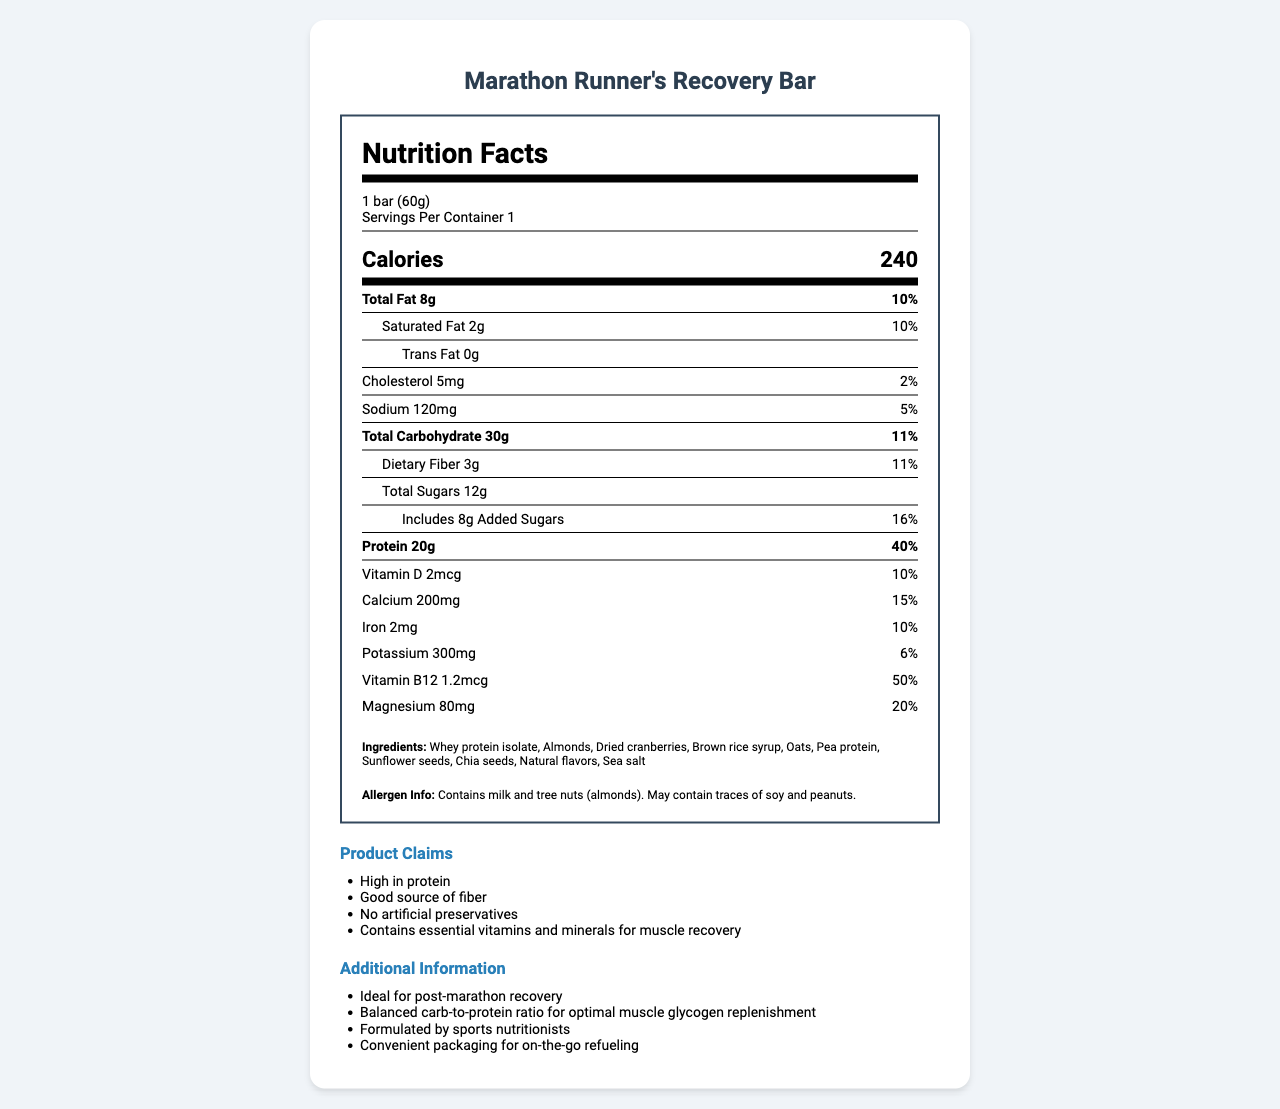What is the serving size of the product? The document states that the serving size is 1 bar weighing 60 grams.
Answer: 1 bar (60g) How many calories are in one serving of the Marathon Runner's Recovery Bar? According to the nutrition label, each serving contains 240 calories.
Answer: 240 calories How much protein does the Marathon Runner's Recovery Bar contain per serving? The nutrition label indicates that each bar contains 20 grams of protein.
Answer: 20g What is the percentage daily value of protein per serving? The document shows that the protein daily value per serving is 40%.
Answer: 40% What are the main ingredients in the Marathon Runner's Recovery Bar? The ingredients list in the document includes these items.
Answer: Whey protein isolate, Almonds, Dried cranberries, Brown rice syrup, Oats, Pea protein, Sunflower seeds, Chia seeds, Natural flavors, Sea salt What percentage of the daily value of Vitamin B12 does one bar provide? A. 10% B. 20% C. 50% D. 100% The document indicates that one bar provides 50% of the daily value of Vitamin B12.
Answer: C. 50% Which mineral is present in the highest amount in the Marathon Runner's Recovery Bar? A. Calcium B. Iron C. Magnesium D. Potassium The nutrition label shows calcium at 200mg, which is the highest amount among the minerals listed.
Answer: A. Calcium Does this recovery bar contain any artificial preservatives? One of the product claims is "No artificial preservatives."
Answer: No Is the product formulated by sports nutritionists? The additional information section mentions it is formulated by sports nutritionists.
Answer: Yes What makes the Marathon Runner's Recovery Bar ideal for post-marathon recovery? The document says it has a balanced carb-to-protein ratio for optimal muscle glycogen replenishment.
Answer: Balanced carb-to-protein ratio for optimal muscle glycogen replenishment Summarize the main purpose and content of the Marathon Runner's Recovery Bar's nutrition label. The main purpose of the label is to highlight the key nutritional benefits of the bar, showing it is formulated to help with muscle recovery after marathons. It provides a detailed breakdown of macronutrients, vitamins, minerals, and other claims like the absence of artificial preservatives.
Answer: The Marathon Runner's Recovery Bar is designed for post-marathon recovery and contains essential nutrients to aid muscle recovery. It provides high protein (20g per bar, 40% daily value), essential vitamins and minerals, and is free from artificial preservatives. The label details the nutritional content, ingredients, allergens, and several claims about the product's benefits. What percentage of daily carbohydrate intake does one bar provide? The document shows that the total carbohydrate per serving is 11% of the daily value.
Answer: 11% What are the allergen warnings for this product? The allergen information in the document lists these specific allergens.
Answer: Contains milk and tree nuts (almonds). May contain traces of soy and peanuts. What is the source of iron in this recovery bar? The document does not specify the source of iron in the ingredients list.
Answer: Not enough information Does the bar include brown rice syrup in its ingredients? The document lists brown rice syrup as one of the ingredients.
Answer: Yes 